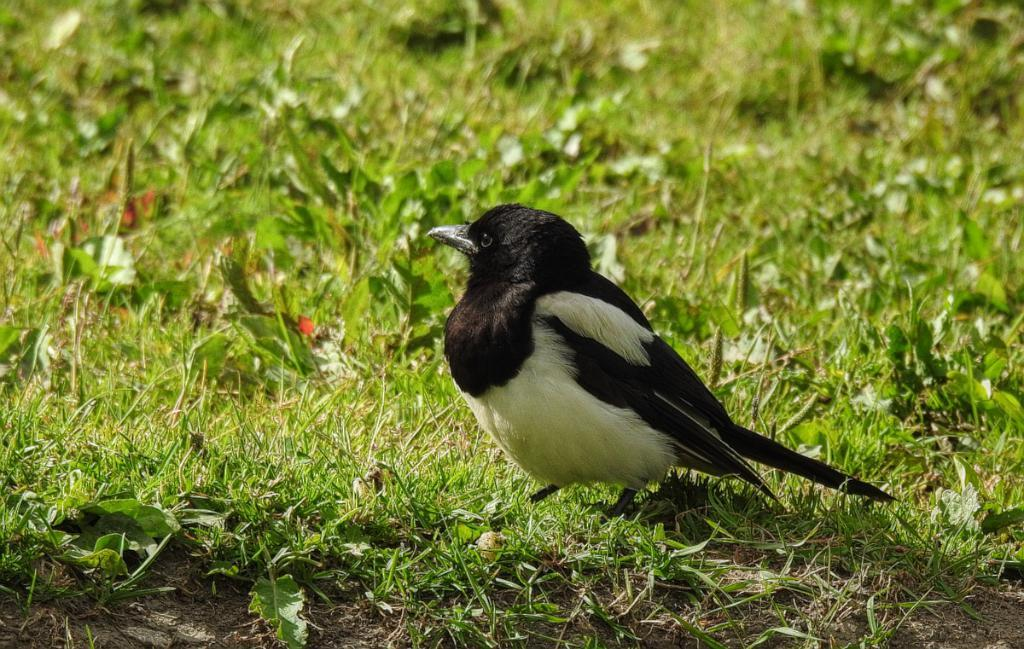What type of animal is in the image? There is a bird in the image. Where is the bird located? The bird is on the grass. Can you describe the background of the image? The background of the image is blurred. What type of tool is the bird using to build a nest in the image? There is no tool, such as a hammer, present in the image. How many ducks are swimming in the pond in the image? There is no pond or ducks present in the image. What occasion is being celebrated in the image? There is no indication of a birthday or any other celebration in the image. 